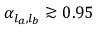Convert formula to latex. <formula><loc_0><loc_0><loc_500><loc_500>\alpha _ { l _ { a } , l _ { b } } \gtrsim 0 . 9 5</formula> 